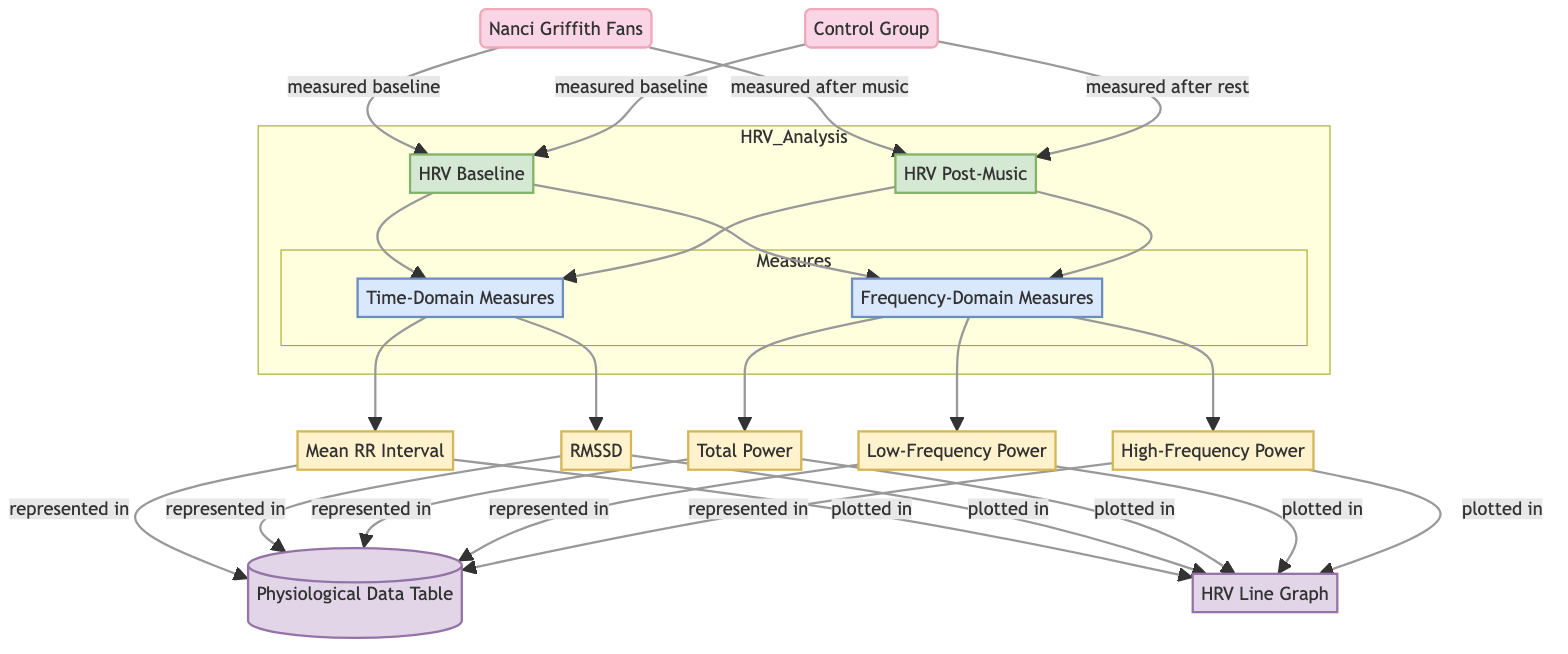What are the two main groups analyzed in the diagram? The diagram identifies two groups: Nanci Griffith Fans and Control Group, represented as distinct nodes in the flowchart.
Answer: Nanci Griffith Fans, Control Group What is measured both at baseline and post-music for the Nanci Griffith Fans? The diagram shows that both HRV Baseline and HRV Post-Music are measured for Nanci Griffith Fans. This indicates the heart rate variability before and after listening to her music.
Answer: HRV Baseline, HRV Post-Music How many categories of measures are there in the diagram? The diagram categorizes the measures into two groups: Time-Domain Measures and Frequency-Domain Measures, which are indicated as sub-nodes under HRV Baseline and HRV Post-Music.
Answer: 2 Which node represents the output of physiological data? The data table node is designated as representing the output where all measurable metrics are included, showing how the data is compiled after analysis.
Answer: Physiological Data Table What type of measures are Mean RR Interval and RMSSD classified under? The diagram categorizes Mean RR Interval and RMSSD under Time-Domain Measures, which signifies their nature as metrics related to time variations in heart rate.
Answer: Time-Domain Measures What is the relationship between HRV Baseline and Frequency-Domain Measures? HRV Baseline is linked to Frequency-Domain Measures through an edge in the diagram, demonstrating that frequency measures are derived from the baseline heart rate variability data.
Answer: Measured through edges What is indicated as the final output of the analysis? The diagram points to both the Line Graph and the Physiological Data Table as final outputs, showing the results of the heart rate variability analysis in visual and tabular formats.
Answer: Line Graph, Physiological Data Table How many physiological metrics are listed under the diagram? There are five physiological metrics listed: Mean RR Interval, RMSSD, Total Power, Low-Frequency Power, High-Frequency Power, which are all connected to the measures.
Answer: 5 What does the post-music measurement entail for the Control Group? The Control Group's post-music measurement refers to their HRV measured after a rest period, indicating that no music was played during this time, serving as a comparison against the music group.
Answer: HRV Post-Music What is the function of the subgraph labeled HRV_Analysis? The subgraph HRV_Analysis is designed to encapsulate the relationship between HRV Baseline and HRV Post-Music, along with their corresponding measures. This structures the data flow for clarity in presentation.
Answer: Encapsulates HRV comparison data 